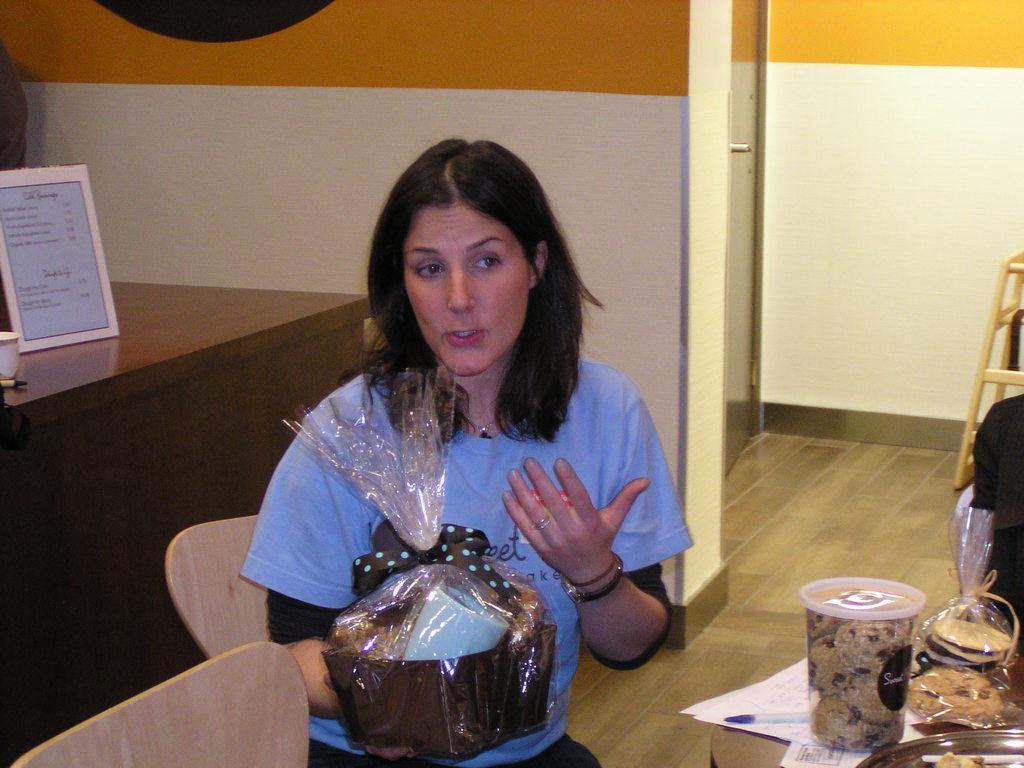Could you give a brief overview of what you see in this image? In this image we can see a woman holding an object and we can also see some food items, paper, board, chairs and wooden bench. 